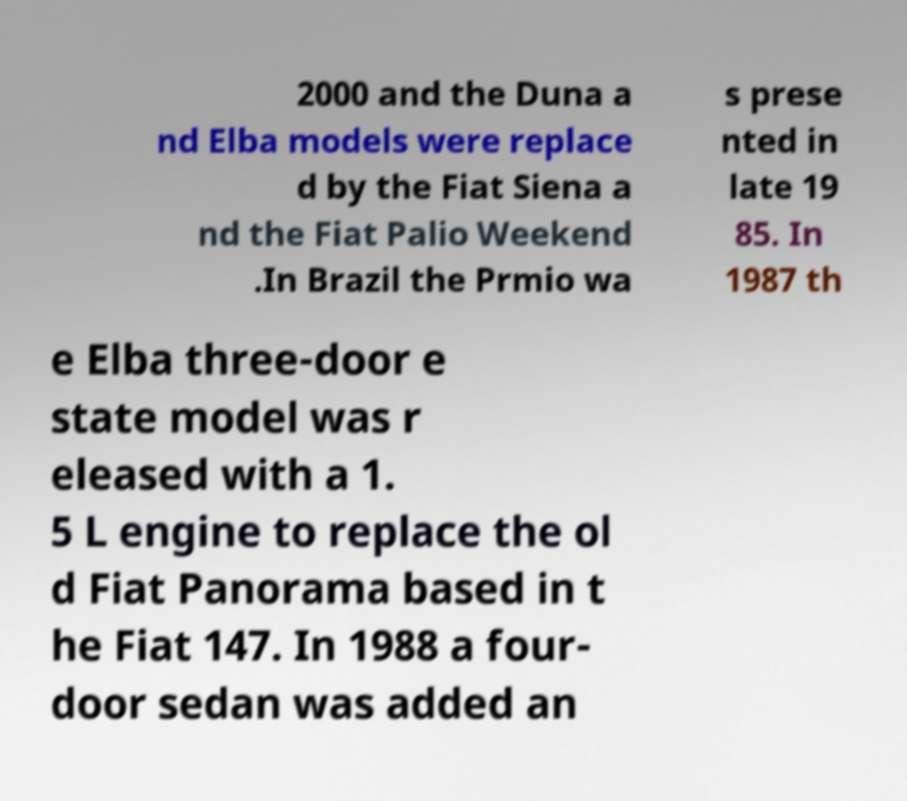Please read and relay the text visible in this image. What does it say? 2000 and the Duna a nd Elba models were replace d by the Fiat Siena a nd the Fiat Palio Weekend .In Brazil the Prmio wa s prese nted in late 19 85. In 1987 th e Elba three-door e state model was r eleased with a 1. 5 L engine to replace the ol d Fiat Panorama based in t he Fiat 147. In 1988 a four- door sedan was added an 